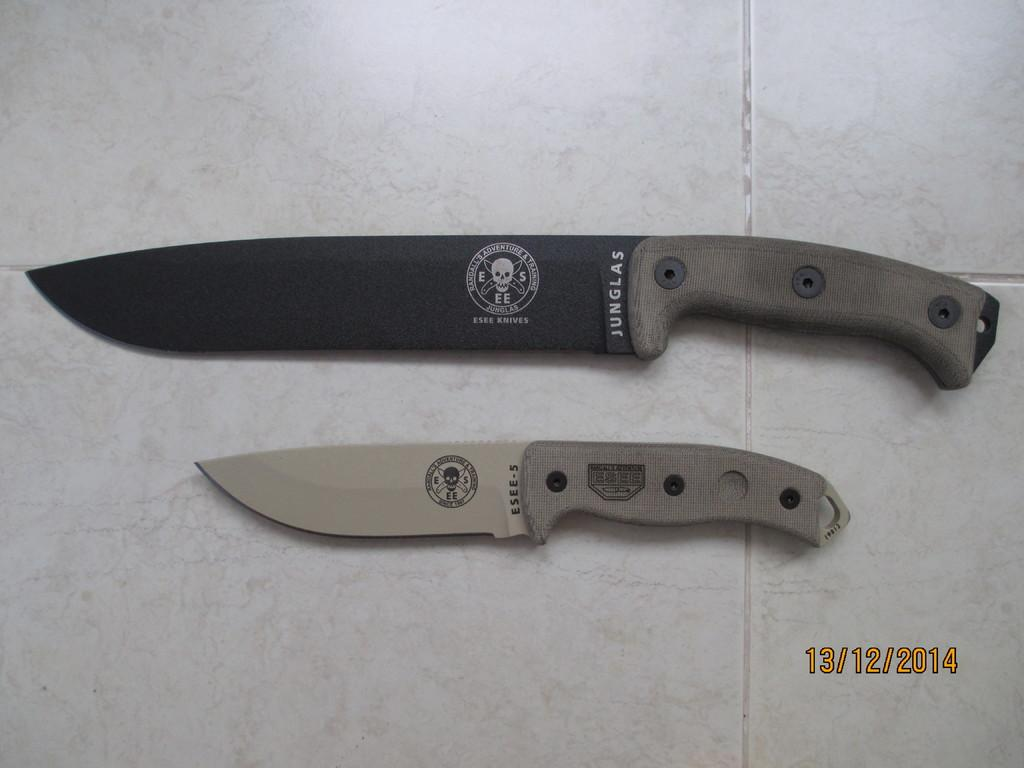<image>
Write a terse but informative summary of the picture. Two knifes are placed together one, an ESEE-5 is smaller than the other. 